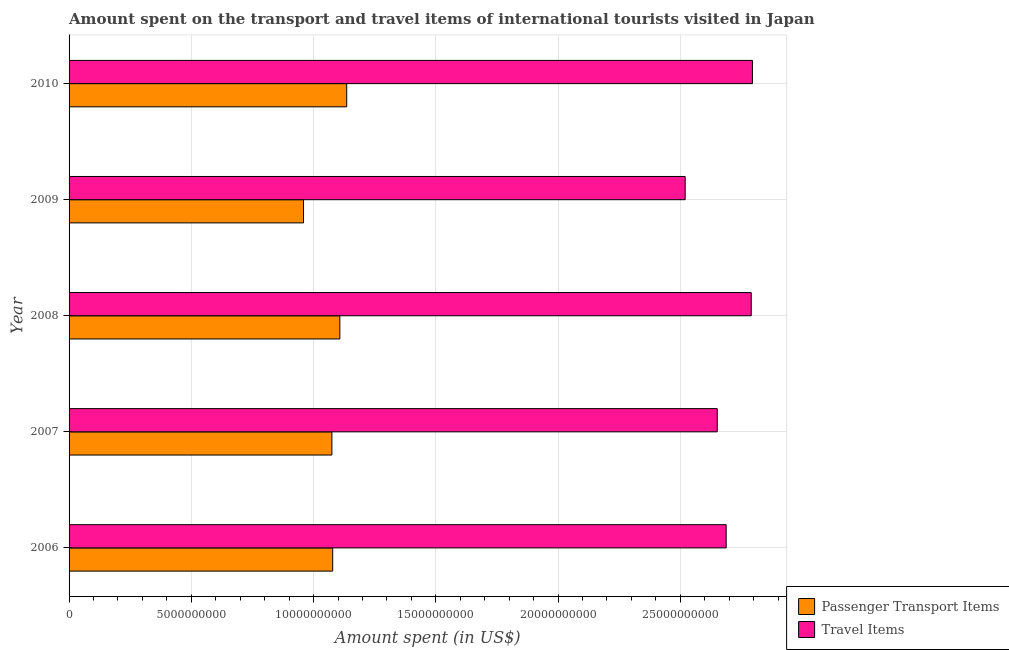How many groups of bars are there?
Offer a very short reply. 5. Are the number of bars on each tick of the Y-axis equal?
Your response must be concise. Yes. How many bars are there on the 1st tick from the top?
Your answer should be compact. 2. What is the label of the 1st group of bars from the top?
Keep it short and to the point. 2010. In how many cases, is the number of bars for a given year not equal to the number of legend labels?
Give a very brief answer. 0. What is the amount spent on passenger transport items in 2009?
Offer a terse response. 9.59e+09. Across all years, what is the maximum amount spent in travel items?
Provide a succinct answer. 2.80e+1. Across all years, what is the minimum amount spent on passenger transport items?
Your answer should be compact. 9.59e+09. In which year was the amount spent in travel items minimum?
Your answer should be compact. 2009. What is the total amount spent in travel items in the graph?
Your response must be concise. 1.34e+11. What is the difference between the amount spent in travel items in 2006 and that in 2007?
Give a very brief answer. 3.65e+08. What is the difference between the amount spent on passenger transport items in 2008 and the amount spent in travel items in 2010?
Your answer should be compact. -1.69e+1. What is the average amount spent in travel items per year?
Make the answer very short. 2.69e+1. In the year 2010, what is the difference between the amount spent on passenger transport items and amount spent in travel items?
Your response must be concise. -1.66e+1. In how many years, is the amount spent on passenger transport items greater than 28000000000 US$?
Ensure brevity in your answer.  0. Is the amount spent on passenger transport items in 2007 less than that in 2008?
Offer a very short reply. Yes. Is the difference between the amount spent on passenger transport items in 2006 and 2008 greater than the difference between the amount spent in travel items in 2006 and 2008?
Ensure brevity in your answer.  Yes. What is the difference between the highest and the second highest amount spent in travel items?
Your answer should be very brief. 4.90e+07. What is the difference between the highest and the lowest amount spent in travel items?
Offer a very short reply. 2.75e+09. In how many years, is the amount spent on passenger transport items greater than the average amount spent on passenger transport items taken over all years?
Provide a succinct answer. 4. What does the 2nd bar from the top in 2010 represents?
Your answer should be compact. Passenger Transport Items. What does the 2nd bar from the bottom in 2008 represents?
Offer a terse response. Travel Items. How many years are there in the graph?
Provide a succinct answer. 5. Are the values on the major ticks of X-axis written in scientific E-notation?
Give a very brief answer. No. Where does the legend appear in the graph?
Give a very brief answer. Bottom right. How many legend labels are there?
Provide a short and direct response. 2. What is the title of the graph?
Your answer should be compact. Amount spent on the transport and travel items of international tourists visited in Japan. Does "Primary school" appear as one of the legend labels in the graph?
Offer a terse response. No. What is the label or title of the X-axis?
Ensure brevity in your answer.  Amount spent (in US$). What is the Amount spent (in US$) of Passenger Transport Items in 2006?
Your response must be concise. 1.08e+1. What is the Amount spent (in US$) in Travel Items in 2006?
Your answer should be compact. 2.69e+1. What is the Amount spent (in US$) in Passenger Transport Items in 2007?
Offer a very short reply. 1.08e+1. What is the Amount spent (in US$) in Travel Items in 2007?
Offer a very short reply. 2.65e+1. What is the Amount spent (in US$) in Passenger Transport Items in 2008?
Offer a terse response. 1.11e+1. What is the Amount spent (in US$) in Travel Items in 2008?
Keep it short and to the point. 2.79e+1. What is the Amount spent (in US$) of Passenger Transport Items in 2009?
Offer a very short reply. 9.59e+09. What is the Amount spent (in US$) of Travel Items in 2009?
Offer a terse response. 2.52e+1. What is the Amount spent (in US$) of Passenger Transport Items in 2010?
Provide a short and direct response. 1.14e+1. What is the Amount spent (in US$) in Travel Items in 2010?
Your response must be concise. 2.80e+1. Across all years, what is the maximum Amount spent (in US$) in Passenger Transport Items?
Offer a terse response. 1.14e+1. Across all years, what is the maximum Amount spent (in US$) of Travel Items?
Your answer should be compact. 2.80e+1. Across all years, what is the minimum Amount spent (in US$) in Passenger Transport Items?
Make the answer very short. 9.59e+09. Across all years, what is the minimum Amount spent (in US$) of Travel Items?
Offer a terse response. 2.52e+1. What is the total Amount spent (in US$) in Passenger Transport Items in the graph?
Offer a terse response. 5.36e+1. What is the total Amount spent (in US$) of Travel Items in the graph?
Ensure brevity in your answer.  1.34e+11. What is the difference between the Amount spent (in US$) in Passenger Transport Items in 2006 and that in 2007?
Your response must be concise. 3.30e+07. What is the difference between the Amount spent (in US$) in Travel Items in 2006 and that in 2007?
Offer a terse response. 3.65e+08. What is the difference between the Amount spent (in US$) of Passenger Transport Items in 2006 and that in 2008?
Make the answer very short. -2.92e+08. What is the difference between the Amount spent (in US$) of Travel Items in 2006 and that in 2008?
Your response must be concise. -1.02e+09. What is the difference between the Amount spent (in US$) in Passenger Transport Items in 2006 and that in 2009?
Offer a terse response. 1.19e+09. What is the difference between the Amount spent (in US$) of Travel Items in 2006 and that in 2009?
Keep it short and to the point. 1.68e+09. What is the difference between the Amount spent (in US$) of Passenger Transport Items in 2006 and that in 2010?
Provide a short and direct response. -5.73e+08. What is the difference between the Amount spent (in US$) in Travel Items in 2006 and that in 2010?
Offer a terse response. -1.07e+09. What is the difference between the Amount spent (in US$) of Passenger Transport Items in 2007 and that in 2008?
Your response must be concise. -3.25e+08. What is the difference between the Amount spent (in US$) of Travel Items in 2007 and that in 2008?
Offer a terse response. -1.39e+09. What is the difference between the Amount spent (in US$) in Passenger Transport Items in 2007 and that in 2009?
Provide a short and direct response. 1.16e+09. What is the difference between the Amount spent (in US$) in Travel Items in 2007 and that in 2009?
Provide a succinct answer. 1.31e+09. What is the difference between the Amount spent (in US$) in Passenger Transport Items in 2007 and that in 2010?
Give a very brief answer. -6.06e+08. What is the difference between the Amount spent (in US$) in Travel Items in 2007 and that in 2010?
Keep it short and to the point. -1.44e+09. What is the difference between the Amount spent (in US$) in Passenger Transport Items in 2008 and that in 2009?
Keep it short and to the point. 1.49e+09. What is the difference between the Amount spent (in US$) in Travel Items in 2008 and that in 2009?
Make the answer very short. 2.70e+09. What is the difference between the Amount spent (in US$) of Passenger Transport Items in 2008 and that in 2010?
Offer a terse response. -2.81e+08. What is the difference between the Amount spent (in US$) in Travel Items in 2008 and that in 2010?
Your answer should be very brief. -4.90e+07. What is the difference between the Amount spent (in US$) in Passenger Transport Items in 2009 and that in 2010?
Make the answer very short. -1.77e+09. What is the difference between the Amount spent (in US$) in Travel Items in 2009 and that in 2010?
Offer a terse response. -2.75e+09. What is the difference between the Amount spent (in US$) in Passenger Transport Items in 2006 and the Amount spent (in US$) in Travel Items in 2007?
Provide a short and direct response. -1.57e+1. What is the difference between the Amount spent (in US$) of Passenger Transport Items in 2006 and the Amount spent (in US$) of Travel Items in 2008?
Provide a succinct answer. -1.71e+1. What is the difference between the Amount spent (in US$) of Passenger Transport Items in 2006 and the Amount spent (in US$) of Travel Items in 2009?
Ensure brevity in your answer.  -1.44e+1. What is the difference between the Amount spent (in US$) in Passenger Transport Items in 2006 and the Amount spent (in US$) in Travel Items in 2010?
Your response must be concise. -1.72e+1. What is the difference between the Amount spent (in US$) of Passenger Transport Items in 2007 and the Amount spent (in US$) of Travel Items in 2008?
Make the answer very short. -1.72e+1. What is the difference between the Amount spent (in US$) in Passenger Transport Items in 2007 and the Amount spent (in US$) in Travel Items in 2009?
Make the answer very short. -1.44e+1. What is the difference between the Amount spent (in US$) in Passenger Transport Items in 2007 and the Amount spent (in US$) in Travel Items in 2010?
Provide a succinct answer. -1.72e+1. What is the difference between the Amount spent (in US$) in Passenger Transport Items in 2008 and the Amount spent (in US$) in Travel Items in 2009?
Offer a terse response. -1.41e+1. What is the difference between the Amount spent (in US$) in Passenger Transport Items in 2008 and the Amount spent (in US$) in Travel Items in 2010?
Your answer should be compact. -1.69e+1. What is the difference between the Amount spent (in US$) of Passenger Transport Items in 2009 and the Amount spent (in US$) of Travel Items in 2010?
Keep it short and to the point. -1.84e+1. What is the average Amount spent (in US$) of Passenger Transport Items per year?
Your answer should be compact. 1.07e+1. What is the average Amount spent (in US$) in Travel Items per year?
Give a very brief answer. 2.69e+1. In the year 2006, what is the difference between the Amount spent (in US$) in Passenger Transport Items and Amount spent (in US$) in Travel Items?
Keep it short and to the point. -1.61e+1. In the year 2007, what is the difference between the Amount spent (in US$) in Passenger Transport Items and Amount spent (in US$) in Travel Items?
Your answer should be compact. -1.58e+1. In the year 2008, what is the difference between the Amount spent (in US$) in Passenger Transport Items and Amount spent (in US$) in Travel Items?
Your answer should be very brief. -1.68e+1. In the year 2009, what is the difference between the Amount spent (in US$) of Passenger Transport Items and Amount spent (in US$) of Travel Items?
Your response must be concise. -1.56e+1. In the year 2010, what is the difference between the Amount spent (in US$) in Passenger Transport Items and Amount spent (in US$) in Travel Items?
Your answer should be very brief. -1.66e+1. What is the ratio of the Amount spent (in US$) of Passenger Transport Items in 2006 to that in 2007?
Your answer should be compact. 1. What is the ratio of the Amount spent (in US$) of Travel Items in 2006 to that in 2007?
Provide a short and direct response. 1.01. What is the ratio of the Amount spent (in US$) in Passenger Transport Items in 2006 to that in 2008?
Offer a very short reply. 0.97. What is the ratio of the Amount spent (in US$) of Travel Items in 2006 to that in 2008?
Your answer should be very brief. 0.96. What is the ratio of the Amount spent (in US$) in Passenger Transport Items in 2006 to that in 2009?
Your answer should be very brief. 1.12. What is the ratio of the Amount spent (in US$) in Travel Items in 2006 to that in 2009?
Make the answer very short. 1.07. What is the ratio of the Amount spent (in US$) of Passenger Transport Items in 2006 to that in 2010?
Offer a terse response. 0.95. What is the ratio of the Amount spent (in US$) of Travel Items in 2006 to that in 2010?
Your answer should be very brief. 0.96. What is the ratio of the Amount spent (in US$) in Passenger Transport Items in 2007 to that in 2008?
Provide a succinct answer. 0.97. What is the ratio of the Amount spent (in US$) of Travel Items in 2007 to that in 2008?
Offer a very short reply. 0.95. What is the ratio of the Amount spent (in US$) in Passenger Transport Items in 2007 to that in 2009?
Ensure brevity in your answer.  1.12. What is the ratio of the Amount spent (in US$) of Travel Items in 2007 to that in 2009?
Your answer should be compact. 1.05. What is the ratio of the Amount spent (in US$) of Passenger Transport Items in 2007 to that in 2010?
Offer a very short reply. 0.95. What is the ratio of the Amount spent (in US$) in Travel Items in 2007 to that in 2010?
Provide a succinct answer. 0.95. What is the ratio of the Amount spent (in US$) in Passenger Transport Items in 2008 to that in 2009?
Offer a very short reply. 1.16. What is the ratio of the Amount spent (in US$) in Travel Items in 2008 to that in 2009?
Provide a succinct answer. 1.11. What is the ratio of the Amount spent (in US$) of Passenger Transport Items in 2008 to that in 2010?
Provide a short and direct response. 0.98. What is the ratio of the Amount spent (in US$) in Passenger Transport Items in 2009 to that in 2010?
Provide a short and direct response. 0.84. What is the ratio of the Amount spent (in US$) of Travel Items in 2009 to that in 2010?
Give a very brief answer. 0.9. What is the difference between the highest and the second highest Amount spent (in US$) of Passenger Transport Items?
Provide a short and direct response. 2.81e+08. What is the difference between the highest and the second highest Amount spent (in US$) of Travel Items?
Your response must be concise. 4.90e+07. What is the difference between the highest and the lowest Amount spent (in US$) in Passenger Transport Items?
Provide a short and direct response. 1.77e+09. What is the difference between the highest and the lowest Amount spent (in US$) in Travel Items?
Your response must be concise. 2.75e+09. 